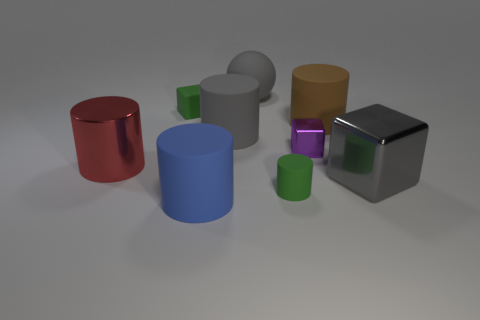There is a metal object that is in front of the tiny metallic thing and right of the red thing; what is its shape?
Make the answer very short. Cube. There is a green rubber thing right of the blue cylinder; how big is it?
Provide a short and direct response. Small. There is a tiny rubber object that is to the right of the cube behind the big brown rubber object; what number of small metallic objects are behind it?
Ensure brevity in your answer.  1. Are there any small green rubber things left of the big blue rubber cylinder?
Your answer should be compact. Yes. How many other things are there of the same size as the purple shiny object?
Give a very brief answer. 2. What is the material of the cube that is left of the gray metallic cube and on the right side of the blue rubber cylinder?
Your response must be concise. Metal. There is a blue object left of the ball; does it have the same shape as the tiny matte object that is in front of the brown cylinder?
Make the answer very short. Yes. What shape is the small green object that is in front of the big metal thing right of the small block that is to the right of the matte cube?
Make the answer very short. Cylinder. How many other objects are there of the same shape as the large brown matte object?
Keep it short and to the point. 4. There is a metal cube that is the same size as the red object; what color is it?
Keep it short and to the point. Gray. 